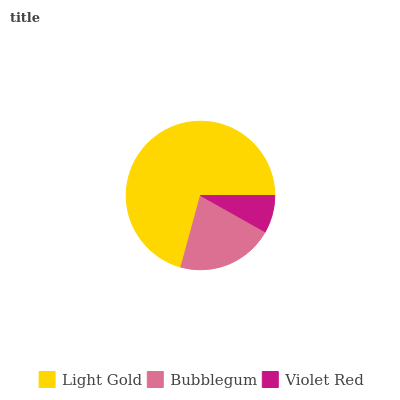Is Violet Red the minimum?
Answer yes or no. Yes. Is Light Gold the maximum?
Answer yes or no. Yes. Is Bubblegum the minimum?
Answer yes or no. No. Is Bubblegum the maximum?
Answer yes or no. No. Is Light Gold greater than Bubblegum?
Answer yes or no. Yes. Is Bubblegum less than Light Gold?
Answer yes or no. Yes. Is Bubblegum greater than Light Gold?
Answer yes or no. No. Is Light Gold less than Bubblegum?
Answer yes or no. No. Is Bubblegum the high median?
Answer yes or no. Yes. Is Bubblegum the low median?
Answer yes or no. Yes. Is Light Gold the high median?
Answer yes or no. No. Is Violet Red the low median?
Answer yes or no. No. 